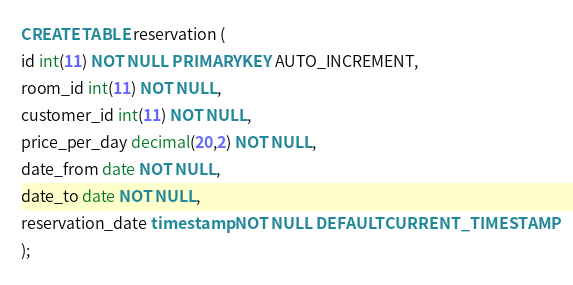Convert code to text. <code><loc_0><loc_0><loc_500><loc_500><_SQL_>CREATE TABLE reservation (
id int(11) NOT NULL PRIMARY KEY AUTO_INCREMENT,
room_id int(11) NOT NULL,
customer_id int(11) NOT NULL,
price_per_day decimal(20,2) NOT NULL,
date_from date NOT NULL,
date_to date NOT NULL,
reservation_date timestamp NOT NULL DEFAULT CURRENT_TIMESTAMP
);</code> 